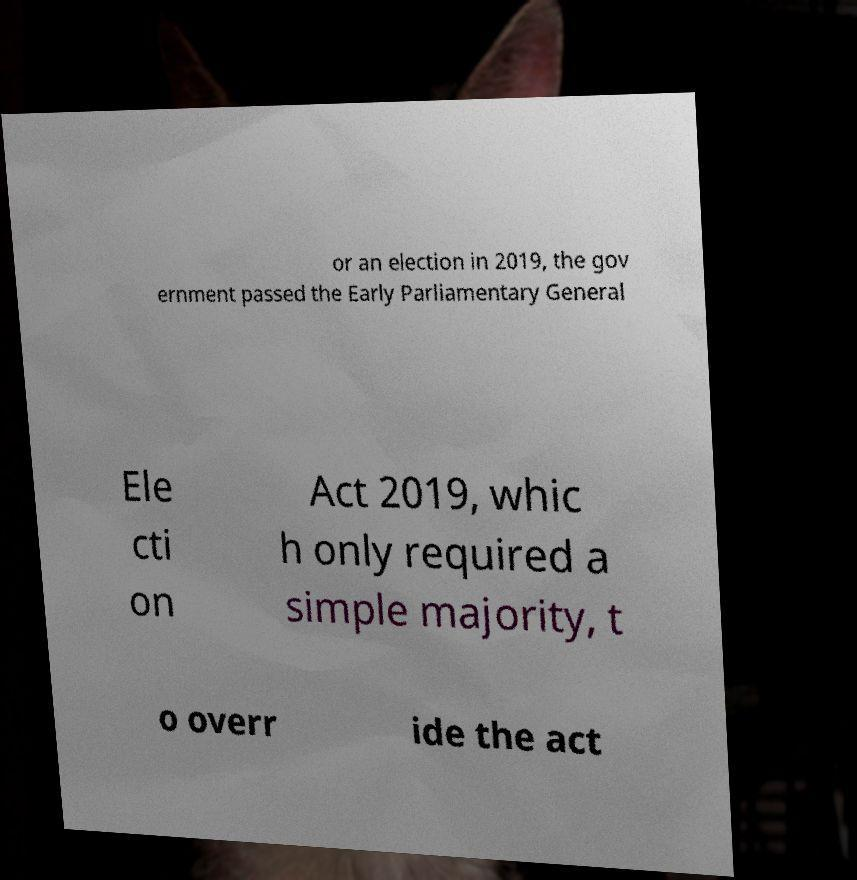Could you assist in decoding the text presented in this image and type it out clearly? or an election in 2019, the gov ernment passed the Early Parliamentary General Ele cti on Act 2019, whic h only required a simple majority, t o overr ide the act 